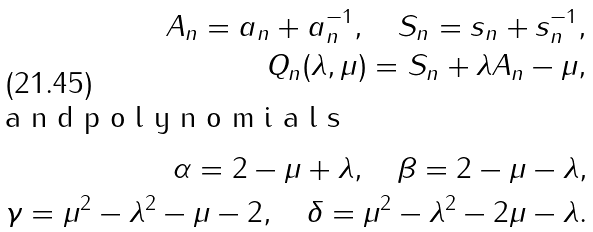Convert formula to latex. <formula><loc_0><loc_0><loc_500><loc_500>A _ { n } = a _ { n } + a _ { n } ^ { - 1 } , \quad S _ { n } = s _ { n } + s _ { n } ^ { - 1 } , \\ Q _ { n } ( \lambda , \mu ) = S _ { n } + \lambda A _ { n } - \mu , \\ \intertext { a n d p o l y n o m i a l s } \alpha = 2 - \mu + \lambda , \quad \beta = 2 - \mu - \lambda , \\ \gamma = \mu ^ { 2 } - \lambda ^ { 2 } - \mu - 2 , \quad \delta = \mu ^ { 2 } - \lambda ^ { 2 } - 2 \mu - \lambda .</formula> 